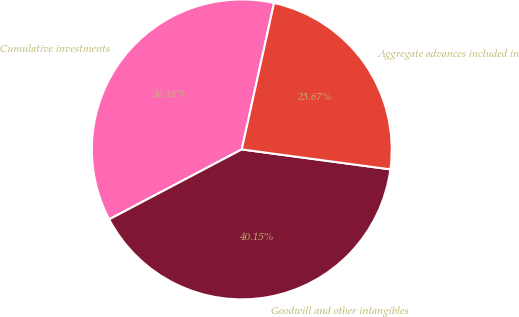Convert chart. <chart><loc_0><loc_0><loc_500><loc_500><pie_chart><fcel>Cumulative investments<fcel>Goodwill and other intangibles<fcel>Aggregate advances included in<nl><fcel>36.18%<fcel>40.15%<fcel>23.67%<nl></chart> 